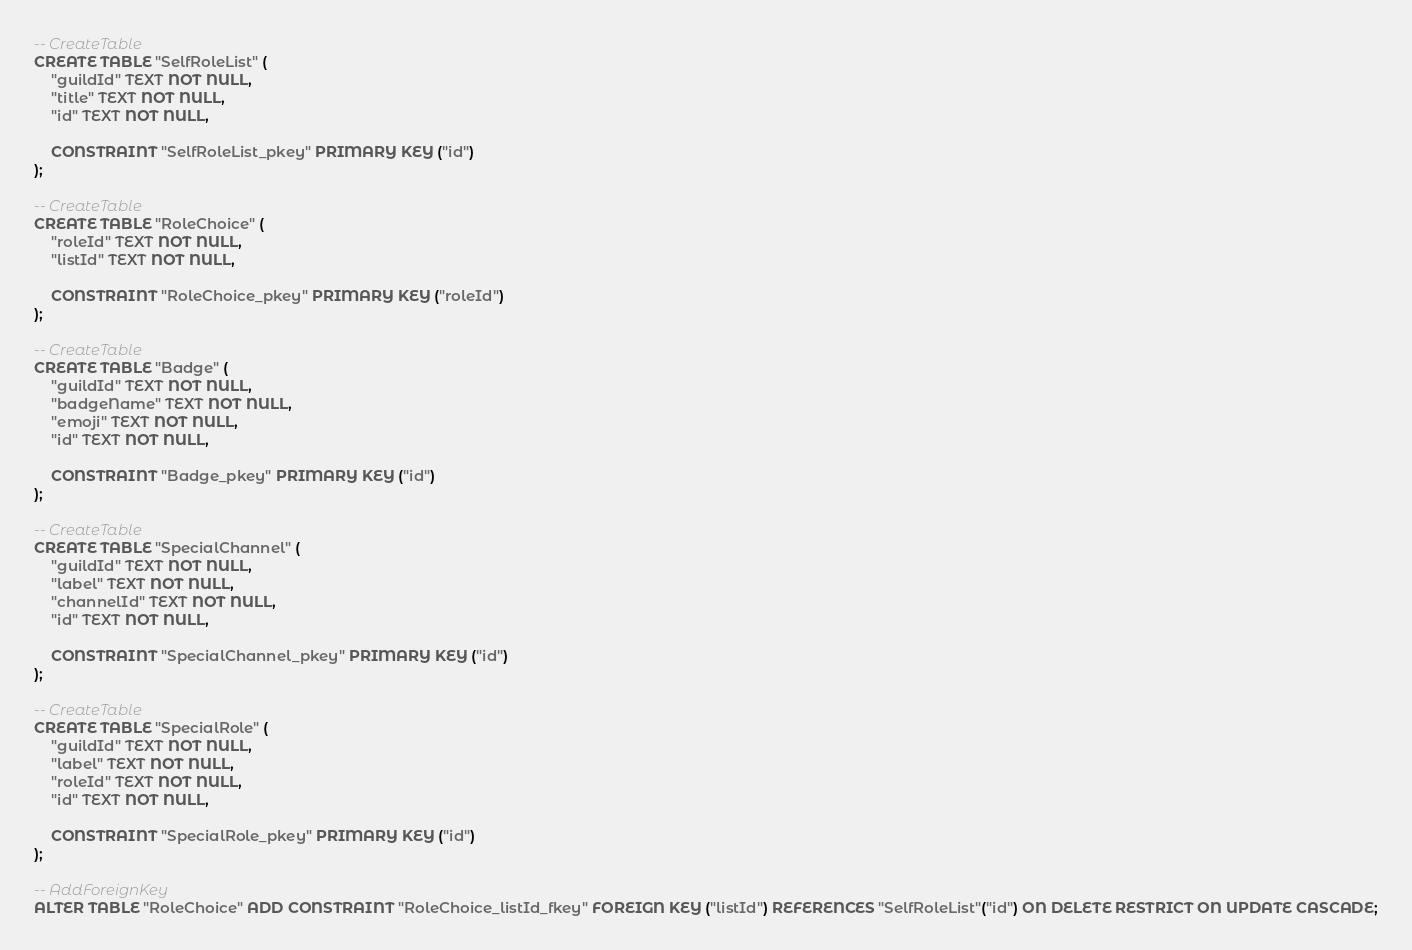<code> <loc_0><loc_0><loc_500><loc_500><_SQL_>-- CreateTable
CREATE TABLE "SelfRoleList" (
    "guildId" TEXT NOT NULL,
    "title" TEXT NOT NULL,
    "id" TEXT NOT NULL,

    CONSTRAINT "SelfRoleList_pkey" PRIMARY KEY ("id")
);

-- CreateTable
CREATE TABLE "RoleChoice" (
    "roleId" TEXT NOT NULL,
    "listId" TEXT NOT NULL,

    CONSTRAINT "RoleChoice_pkey" PRIMARY KEY ("roleId")
);

-- CreateTable
CREATE TABLE "Badge" (
    "guildId" TEXT NOT NULL,
    "badgeName" TEXT NOT NULL,
    "emoji" TEXT NOT NULL,
    "id" TEXT NOT NULL,

    CONSTRAINT "Badge_pkey" PRIMARY KEY ("id")
);

-- CreateTable
CREATE TABLE "SpecialChannel" (
    "guildId" TEXT NOT NULL,
    "label" TEXT NOT NULL,
    "channelId" TEXT NOT NULL,
    "id" TEXT NOT NULL,

    CONSTRAINT "SpecialChannel_pkey" PRIMARY KEY ("id")
);

-- CreateTable
CREATE TABLE "SpecialRole" (
    "guildId" TEXT NOT NULL,
    "label" TEXT NOT NULL,
    "roleId" TEXT NOT NULL,
    "id" TEXT NOT NULL,

    CONSTRAINT "SpecialRole_pkey" PRIMARY KEY ("id")
);

-- AddForeignKey
ALTER TABLE "RoleChoice" ADD CONSTRAINT "RoleChoice_listId_fkey" FOREIGN KEY ("listId") REFERENCES "SelfRoleList"("id") ON DELETE RESTRICT ON UPDATE CASCADE;
</code> 